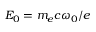Convert formula to latex. <formula><loc_0><loc_0><loc_500><loc_500>E _ { 0 } = m _ { e } c \omega _ { 0 } / e</formula> 